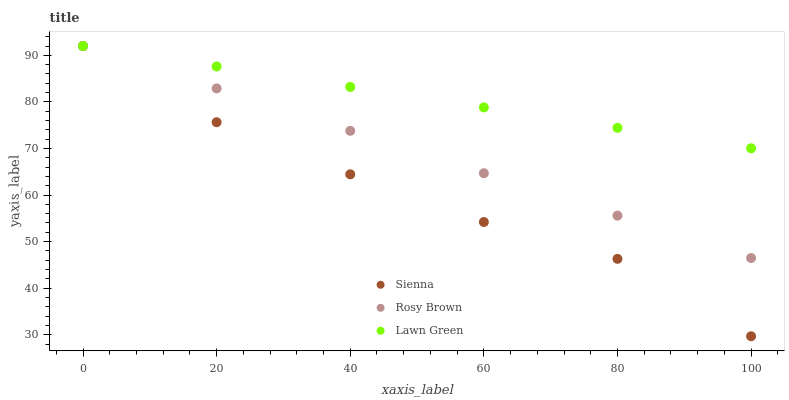Does Sienna have the minimum area under the curve?
Answer yes or no. Yes. Does Lawn Green have the maximum area under the curve?
Answer yes or no. Yes. Does Rosy Brown have the minimum area under the curve?
Answer yes or no. No. Does Rosy Brown have the maximum area under the curve?
Answer yes or no. No. Is Lawn Green the smoothest?
Answer yes or no. Yes. Is Sienna the roughest?
Answer yes or no. Yes. Is Rosy Brown the smoothest?
Answer yes or no. No. Is Rosy Brown the roughest?
Answer yes or no. No. Does Sienna have the lowest value?
Answer yes or no. Yes. Does Rosy Brown have the lowest value?
Answer yes or no. No. Does Rosy Brown have the highest value?
Answer yes or no. Yes. Does Lawn Green intersect Sienna?
Answer yes or no. Yes. Is Lawn Green less than Sienna?
Answer yes or no. No. Is Lawn Green greater than Sienna?
Answer yes or no. No. 